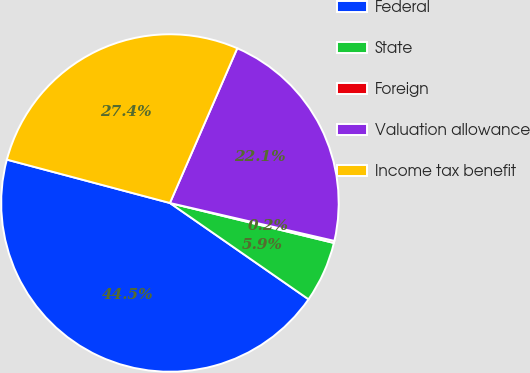Convert chart to OTSL. <chart><loc_0><loc_0><loc_500><loc_500><pie_chart><fcel>Federal<fcel>State<fcel>Foreign<fcel>Valuation allowance<fcel>Income tax benefit<nl><fcel>44.47%<fcel>5.86%<fcel>0.2%<fcel>22.07%<fcel>27.39%<nl></chart> 